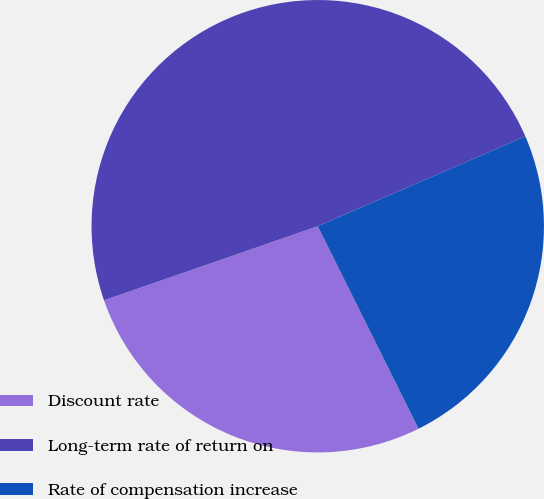Convert chart to OTSL. <chart><loc_0><loc_0><loc_500><loc_500><pie_chart><fcel>Discount rate<fcel>Long-term rate of return on<fcel>Rate of compensation increase<nl><fcel>27.04%<fcel>48.81%<fcel>24.15%<nl></chart> 